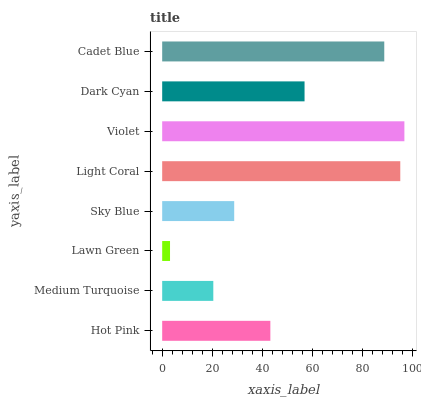Is Lawn Green the minimum?
Answer yes or no. Yes. Is Violet the maximum?
Answer yes or no. Yes. Is Medium Turquoise the minimum?
Answer yes or no. No. Is Medium Turquoise the maximum?
Answer yes or no. No. Is Hot Pink greater than Medium Turquoise?
Answer yes or no. Yes. Is Medium Turquoise less than Hot Pink?
Answer yes or no. Yes. Is Medium Turquoise greater than Hot Pink?
Answer yes or no. No. Is Hot Pink less than Medium Turquoise?
Answer yes or no. No. Is Dark Cyan the high median?
Answer yes or no. Yes. Is Hot Pink the low median?
Answer yes or no. Yes. Is Medium Turquoise the high median?
Answer yes or no. No. Is Dark Cyan the low median?
Answer yes or no. No. 